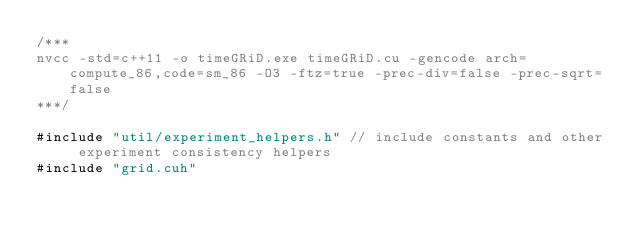Convert code to text. <code><loc_0><loc_0><loc_500><loc_500><_Cuda_>/***
nvcc -std=c++11 -o timeGRiD.exe timeGRiD.cu -gencode arch=compute_86,code=sm_86 -O3 -ftz=true -prec-div=false -prec-sqrt=false
***/

#include "util/experiment_helpers.h" // include constants and other experiment consistency helpers
#include "grid.cuh"
</code> 